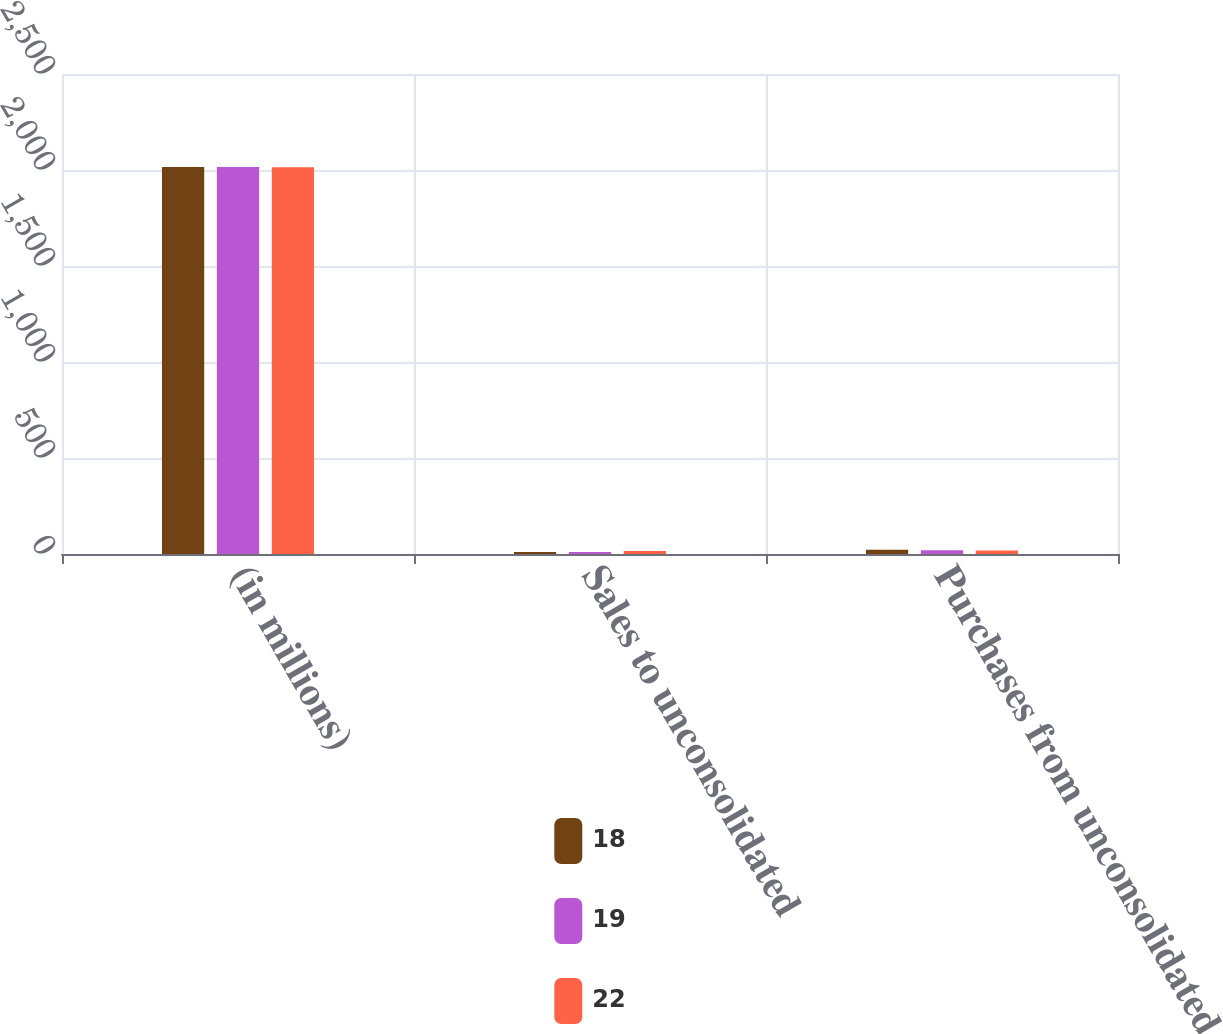Convert chart. <chart><loc_0><loc_0><loc_500><loc_500><stacked_bar_chart><ecel><fcel>(in millions)<fcel>Sales to unconsolidated<fcel>Purchases from unconsolidated<nl><fcel>18<fcel>2016<fcel>11<fcel>22<nl><fcel>19<fcel>2015<fcel>11<fcel>19<nl><fcel>22<fcel>2014<fcel>16<fcel>18<nl></chart> 